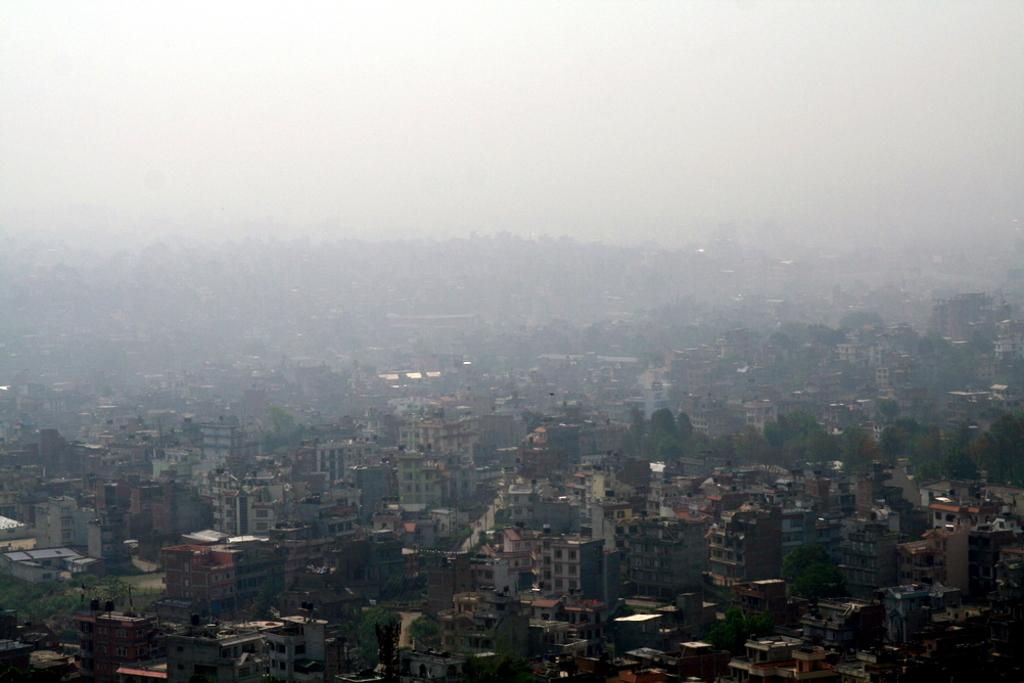What type of structures are present in the image? There are buildings in the image. What can be seen on top of the buildings? There are water tanks on top of the buildings. What type of vegetation is visible in the image? There are trees in the image. What is visible at the top of the image? The sky is visible at the top of the image. How many sisters are sitting on the water tanks in the image? There are no sisters present in the image; it features buildings with water tanks on top. What type of bird can be seen flying in the image? There is no bird visible in the image; it only shows buildings, water tanks, trees, and the sky. 